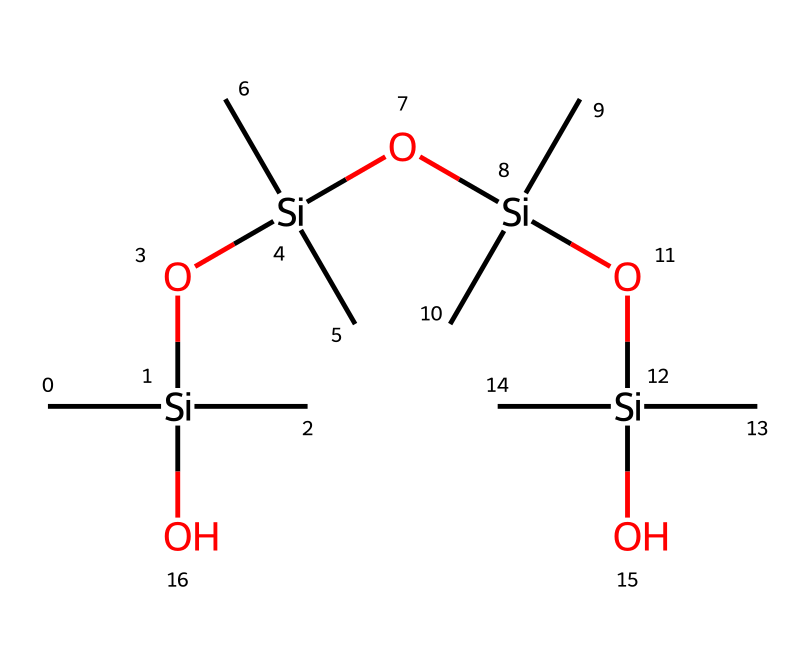What is the main element found in the structure of Silly Putty? The structure consists predominantly of silicon atoms, which can be identified by the presence of the 'Si' symbols in the SMILES representation.
Answer: silicon How many silicon atoms are in the molecular composition of Silly Putty? By counting the number of 'Si' in the SMILES, there are four silicon atoms present.
Answer: four What functional groups are indicated in the SMILES representation of Silly Putty? The presence of the 'O' symbols suggests that there are silanol (hydroxyl) functional groups in the structure, indicating the presence of silicon-oxygen bonds.
Answer: silanol What type of molecular structure does Silly Putty exhibit? The repeating units of silicone and silanol functional groups denote a polymer structure, which allows it to exhibit non-Newtonian fluid properties.
Answer: polymer Why does Silly Putty behave as a non-Newtonian fluid? The molecular structure, which includes flexible and linear polymer chains, allows for changes in viscosity under varying stress conditions, characteristic of non-Newtonian fluids.
Answer: viscosity changes How many hydroxyl groups are present in the Silly Putty structure? Each 'O' in the SMILES represents a hydroxyl functional group, and there are three hydroxyl groups connected to the silicon atoms, which can be counted directly.
Answer: three What property of Silly Putty relates to its non-Newtonian characteristics? The property of Silly Putty that relates to its non-Newtonian characteristics is its shear-thickening behavior, meaning it increases in viscosity when subjected to stress.
Answer: shear-thickening behavior 